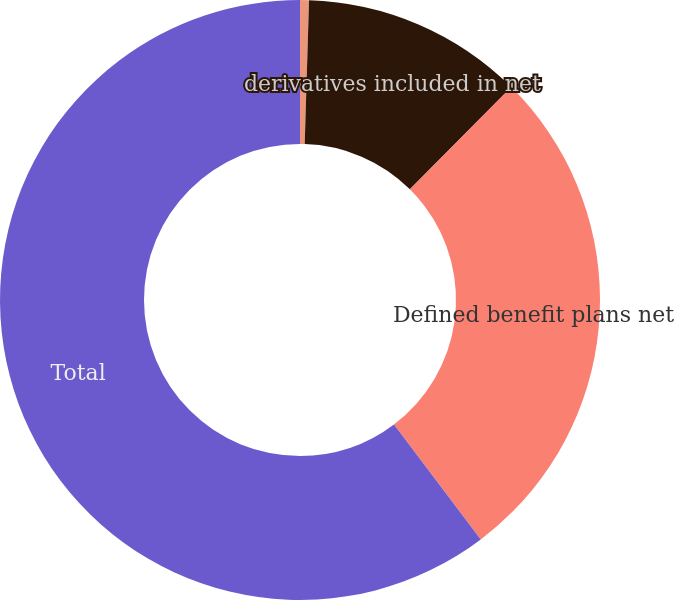<chart> <loc_0><loc_0><loc_500><loc_500><pie_chart><fcel>Net unrealized gains (losses)<fcel>derivatives included in net<fcel>Defined benefit plans net<fcel>Total<nl><fcel>0.48%<fcel>11.96%<fcel>27.27%<fcel>60.29%<nl></chart> 